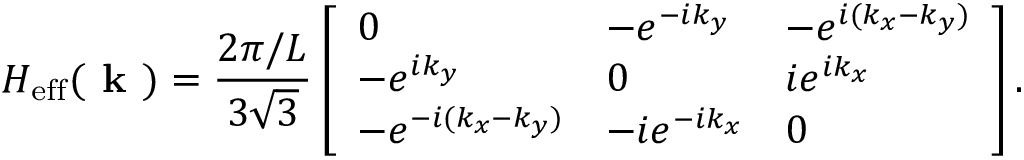Convert formula to latex. <formula><loc_0><loc_0><loc_500><loc_500>H _ { e f f } ( k ) = \frac { 2 \pi / L } { 3 \sqrt { 3 } } \left [ \begin{array} { l l l } { 0 } & { - e ^ { - i k _ { y } } } & { - e ^ { i ( k _ { x } - k _ { y } ) } } \\ { - e ^ { i k _ { y } } } & { 0 } & { i e ^ { i k _ { x } } } \\ { - e ^ { - i ( k _ { x } - k _ { y } ) } } & { - i e ^ { - i k _ { x } } } & { 0 } \end{array} \right ] .</formula> 